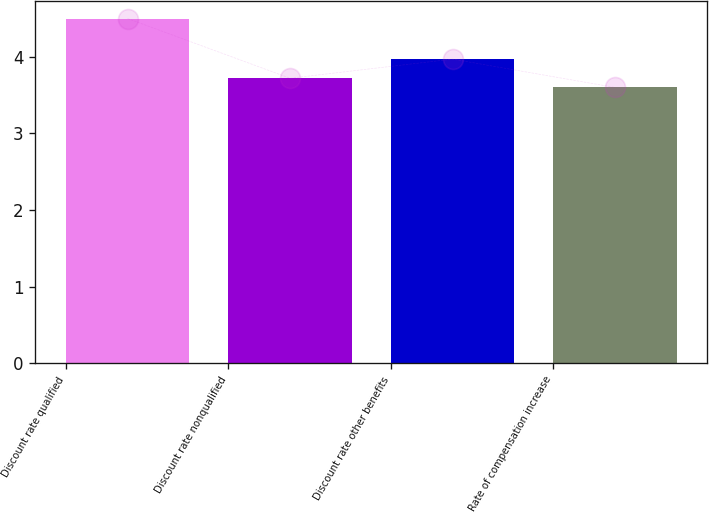Convert chart to OTSL. <chart><loc_0><loc_0><loc_500><loc_500><bar_chart><fcel>Discount rate qualified<fcel>Discount rate nonqualified<fcel>Discount rate other benefits<fcel>Rate of compensation increase<nl><fcel>4.5<fcel>3.72<fcel>3.97<fcel>3.6<nl></chart> 